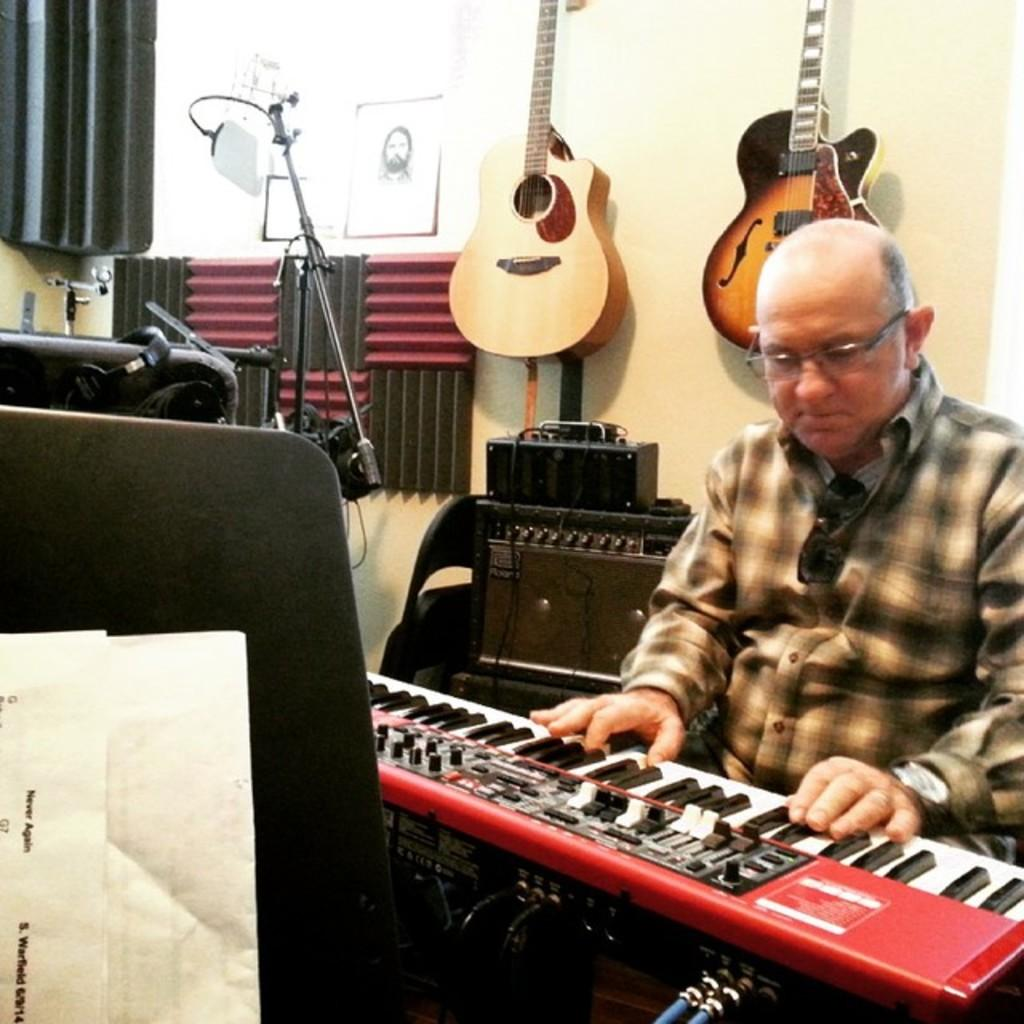What is the man in the image doing? The man is sitting and playing a piano. What other musical instruments can be seen in the image? There are other musical instruments visible in the background. What is located behind the man in the image? There is a wall in the background of the image. How many games of addition is the man playing in the image? There is no indication of any games or addition in the image; the man is playing a piano. 